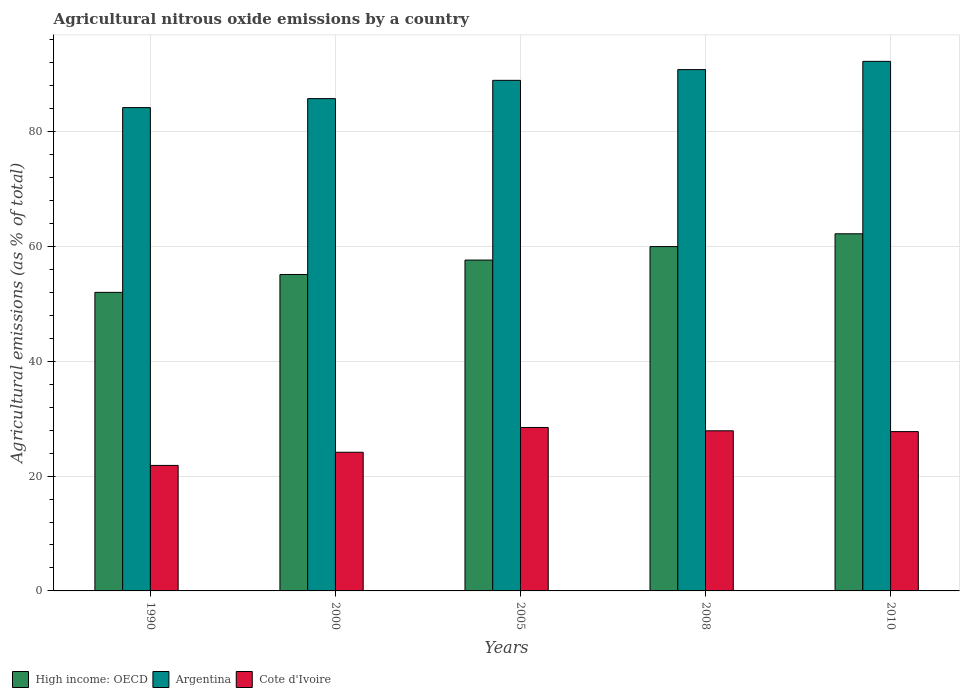How many groups of bars are there?
Offer a very short reply. 5. Are the number of bars per tick equal to the number of legend labels?
Provide a short and direct response. Yes. Are the number of bars on each tick of the X-axis equal?
Provide a succinct answer. Yes. What is the label of the 3rd group of bars from the left?
Your response must be concise. 2005. What is the amount of agricultural nitrous oxide emitted in Cote d'Ivoire in 2010?
Offer a very short reply. 27.74. Across all years, what is the maximum amount of agricultural nitrous oxide emitted in Argentina?
Keep it short and to the point. 92.22. Across all years, what is the minimum amount of agricultural nitrous oxide emitted in Argentina?
Keep it short and to the point. 84.16. In which year was the amount of agricultural nitrous oxide emitted in Argentina maximum?
Ensure brevity in your answer.  2010. In which year was the amount of agricultural nitrous oxide emitted in Argentina minimum?
Make the answer very short. 1990. What is the total amount of agricultural nitrous oxide emitted in Argentina in the graph?
Offer a very short reply. 441.8. What is the difference between the amount of agricultural nitrous oxide emitted in High income: OECD in 1990 and that in 2008?
Give a very brief answer. -7.97. What is the difference between the amount of agricultural nitrous oxide emitted in Argentina in 2008 and the amount of agricultural nitrous oxide emitted in High income: OECD in 1990?
Give a very brief answer. 38.79. What is the average amount of agricultural nitrous oxide emitted in Cote d'Ivoire per year?
Your answer should be compact. 26.02. In the year 2000, what is the difference between the amount of agricultural nitrous oxide emitted in High income: OECD and amount of agricultural nitrous oxide emitted in Cote d'Ivoire?
Your response must be concise. 30.96. What is the ratio of the amount of agricultural nitrous oxide emitted in High income: OECD in 1990 to that in 2005?
Keep it short and to the point. 0.9. Is the difference between the amount of agricultural nitrous oxide emitted in High income: OECD in 1990 and 2010 greater than the difference between the amount of agricultural nitrous oxide emitted in Cote d'Ivoire in 1990 and 2010?
Make the answer very short. No. What is the difference between the highest and the second highest amount of agricultural nitrous oxide emitted in Cote d'Ivoire?
Ensure brevity in your answer.  0.58. What is the difference between the highest and the lowest amount of agricultural nitrous oxide emitted in High income: OECD?
Offer a terse response. 10.2. In how many years, is the amount of agricultural nitrous oxide emitted in Cote d'Ivoire greater than the average amount of agricultural nitrous oxide emitted in Cote d'Ivoire taken over all years?
Provide a short and direct response. 3. Is the sum of the amount of agricultural nitrous oxide emitted in Cote d'Ivoire in 1990 and 2008 greater than the maximum amount of agricultural nitrous oxide emitted in Argentina across all years?
Offer a terse response. No. What does the 1st bar from the left in 2008 represents?
Offer a terse response. High income: OECD. What does the 3rd bar from the right in 2000 represents?
Give a very brief answer. High income: OECD. Is it the case that in every year, the sum of the amount of agricultural nitrous oxide emitted in Cote d'Ivoire and amount of agricultural nitrous oxide emitted in Argentina is greater than the amount of agricultural nitrous oxide emitted in High income: OECD?
Offer a terse response. Yes. How many bars are there?
Provide a succinct answer. 15. Are all the bars in the graph horizontal?
Make the answer very short. No. How many years are there in the graph?
Offer a terse response. 5. How many legend labels are there?
Your answer should be very brief. 3. What is the title of the graph?
Offer a very short reply. Agricultural nitrous oxide emissions by a country. What is the label or title of the X-axis?
Offer a terse response. Years. What is the label or title of the Y-axis?
Give a very brief answer. Agricultural emissions (as % of total). What is the Agricultural emissions (as % of total) in High income: OECD in 1990?
Offer a terse response. 51.99. What is the Agricultural emissions (as % of total) of Argentina in 1990?
Ensure brevity in your answer.  84.16. What is the Agricultural emissions (as % of total) of Cote d'Ivoire in 1990?
Keep it short and to the point. 21.85. What is the Agricultural emissions (as % of total) of High income: OECD in 2000?
Ensure brevity in your answer.  55.1. What is the Agricultural emissions (as % of total) in Argentina in 2000?
Ensure brevity in your answer.  85.73. What is the Agricultural emissions (as % of total) of Cote d'Ivoire in 2000?
Give a very brief answer. 24.15. What is the Agricultural emissions (as % of total) of High income: OECD in 2005?
Your answer should be very brief. 57.61. What is the Agricultural emissions (as % of total) of Argentina in 2005?
Your response must be concise. 88.91. What is the Agricultural emissions (as % of total) in Cote d'Ivoire in 2005?
Offer a very short reply. 28.46. What is the Agricultural emissions (as % of total) in High income: OECD in 2008?
Provide a short and direct response. 59.96. What is the Agricultural emissions (as % of total) of Argentina in 2008?
Keep it short and to the point. 90.78. What is the Agricultural emissions (as % of total) of Cote d'Ivoire in 2008?
Provide a succinct answer. 27.88. What is the Agricultural emissions (as % of total) of High income: OECD in 2010?
Your answer should be very brief. 62.19. What is the Agricultural emissions (as % of total) in Argentina in 2010?
Keep it short and to the point. 92.22. What is the Agricultural emissions (as % of total) of Cote d'Ivoire in 2010?
Your response must be concise. 27.74. Across all years, what is the maximum Agricultural emissions (as % of total) in High income: OECD?
Offer a very short reply. 62.19. Across all years, what is the maximum Agricultural emissions (as % of total) in Argentina?
Keep it short and to the point. 92.22. Across all years, what is the maximum Agricultural emissions (as % of total) of Cote d'Ivoire?
Keep it short and to the point. 28.46. Across all years, what is the minimum Agricultural emissions (as % of total) in High income: OECD?
Provide a succinct answer. 51.99. Across all years, what is the minimum Agricultural emissions (as % of total) in Argentina?
Offer a terse response. 84.16. Across all years, what is the minimum Agricultural emissions (as % of total) in Cote d'Ivoire?
Provide a succinct answer. 21.85. What is the total Agricultural emissions (as % of total) of High income: OECD in the graph?
Ensure brevity in your answer.  286.86. What is the total Agricultural emissions (as % of total) in Argentina in the graph?
Offer a terse response. 441.8. What is the total Agricultural emissions (as % of total) in Cote d'Ivoire in the graph?
Offer a terse response. 130.09. What is the difference between the Agricultural emissions (as % of total) of High income: OECD in 1990 and that in 2000?
Your answer should be compact. -3.12. What is the difference between the Agricultural emissions (as % of total) in Argentina in 1990 and that in 2000?
Provide a short and direct response. -1.56. What is the difference between the Agricultural emissions (as % of total) of Cote d'Ivoire in 1990 and that in 2000?
Give a very brief answer. -2.29. What is the difference between the Agricultural emissions (as % of total) in High income: OECD in 1990 and that in 2005?
Ensure brevity in your answer.  -5.62. What is the difference between the Agricultural emissions (as % of total) of Argentina in 1990 and that in 2005?
Ensure brevity in your answer.  -4.75. What is the difference between the Agricultural emissions (as % of total) in Cote d'Ivoire in 1990 and that in 2005?
Your answer should be very brief. -6.61. What is the difference between the Agricultural emissions (as % of total) of High income: OECD in 1990 and that in 2008?
Ensure brevity in your answer.  -7.97. What is the difference between the Agricultural emissions (as % of total) in Argentina in 1990 and that in 2008?
Offer a very short reply. -6.62. What is the difference between the Agricultural emissions (as % of total) in Cote d'Ivoire in 1990 and that in 2008?
Ensure brevity in your answer.  -6.03. What is the difference between the Agricultural emissions (as % of total) in High income: OECD in 1990 and that in 2010?
Offer a very short reply. -10.2. What is the difference between the Agricultural emissions (as % of total) of Argentina in 1990 and that in 2010?
Your answer should be very brief. -8.05. What is the difference between the Agricultural emissions (as % of total) in Cote d'Ivoire in 1990 and that in 2010?
Give a very brief answer. -5.89. What is the difference between the Agricultural emissions (as % of total) of High income: OECD in 2000 and that in 2005?
Provide a short and direct response. -2.51. What is the difference between the Agricultural emissions (as % of total) of Argentina in 2000 and that in 2005?
Offer a terse response. -3.18. What is the difference between the Agricultural emissions (as % of total) of Cote d'Ivoire in 2000 and that in 2005?
Give a very brief answer. -4.31. What is the difference between the Agricultural emissions (as % of total) in High income: OECD in 2000 and that in 2008?
Offer a terse response. -4.86. What is the difference between the Agricultural emissions (as % of total) of Argentina in 2000 and that in 2008?
Provide a succinct answer. -5.05. What is the difference between the Agricultural emissions (as % of total) in Cote d'Ivoire in 2000 and that in 2008?
Your answer should be compact. -3.73. What is the difference between the Agricultural emissions (as % of total) of High income: OECD in 2000 and that in 2010?
Provide a short and direct response. -7.09. What is the difference between the Agricultural emissions (as % of total) in Argentina in 2000 and that in 2010?
Your response must be concise. -6.49. What is the difference between the Agricultural emissions (as % of total) in Cote d'Ivoire in 2000 and that in 2010?
Your response must be concise. -3.6. What is the difference between the Agricultural emissions (as % of total) of High income: OECD in 2005 and that in 2008?
Your answer should be very brief. -2.35. What is the difference between the Agricultural emissions (as % of total) in Argentina in 2005 and that in 2008?
Your response must be concise. -1.87. What is the difference between the Agricultural emissions (as % of total) in Cote d'Ivoire in 2005 and that in 2008?
Your answer should be very brief. 0.58. What is the difference between the Agricultural emissions (as % of total) in High income: OECD in 2005 and that in 2010?
Your answer should be very brief. -4.58. What is the difference between the Agricultural emissions (as % of total) in Argentina in 2005 and that in 2010?
Make the answer very short. -3.3. What is the difference between the Agricultural emissions (as % of total) of Cote d'Ivoire in 2005 and that in 2010?
Keep it short and to the point. 0.72. What is the difference between the Agricultural emissions (as % of total) in High income: OECD in 2008 and that in 2010?
Your answer should be very brief. -2.23. What is the difference between the Agricultural emissions (as % of total) of Argentina in 2008 and that in 2010?
Your answer should be compact. -1.44. What is the difference between the Agricultural emissions (as % of total) in Cote d'Ivoire in 2008 and that in 2010?
Your response must be concise. 0.14. What is the difference between the Agricultural emissions (as % of total) in High income: OECD in 1990 and the Agricultural emissions (as % of total) in Argentina in 2000?
Keep it short and to the point. -33.74. What is the difference between the Agricultural emissions (as % of total) in High income: OECD in 1990 and the Agricultural emissions (as % of total) in Cote d'Ivoire in 2000?
Your answer should be very brief. 27.84. What is the difference between the Agricultural emissions (as % of total) of Argentina in 1990 and the Agricultural emissions (as % of total) of Cote d'Ivoire in 2000?
Offer a terse response. 60.02. What is the difference between the Agricultural emissions (as % of total) of High income: OECD in 1990 and the Agricultural emissions (as % of total) of Argentina in 2005?
Your response must be concise. -36.92. What is the difference between the Agricultural emissions (as % of total) of High income: OECD in 1990 and the Agricultural emissions (as % of total) of Cote d'Ivoire in 2005?
Give a very brief answer. 23.53. What is the difference between the Agricultural emissions (as % of total) of Argentina in 1990 and the Agricultural emissions (as % of total) of Cote d'Ivoire in 2005?
Your answer should be very brief. 55.7. What is the difference between the Agricultural emissions (as % of total) in High income: OECD in 1990 and the Agricultural emissions (as % of total) in Argentina in 2008?
Offer a very short reply. -38.79. What is the difference between the Agricultural emissions (as % of total) of High income: OECD in 1990 and the Agricultural emissions (as % of total) of Cote d'Ivoire in 2008?
Offer a terse response. 24.11. What is the difference between the Agricultural emissions (as % of total) of Argentina in 1990 and the Agricultural emissions (as % of total) of Cote d'Ivoire in 2008?
Provide a succinct answer. 56.28. What is the difference between the Agricultural emissions (as % of total) of High income: OECD in 1990 and the Agricultural emissions (as % of total) of Argentina in 2010?
Your answer should be very brief. -40.23. What is the difference between the Agricultural emissions (as % of total) in High income: OECD in 1990 and the Agricultural emissions (as % of total) in Cote d'Ivoire in 2010?
Offer a terse response. 24.24. What is the difference between the Agricultural emissions (as % of total) of Argentina in 1990 and the Agricultural emissions (as % of total) of Cote d'Ivoire in 2010?
Give a very brief answer. 56.42. What is the difference between the Agricultural emissions (as % of total) of High income: OECD in 2000 and the Agricultural emissions (as % of total) of Argentina in 2005?
Your response must be concise. -33.81. What is the difference between the Agricultural emissions (as % of total) of High income: OECD in 2000 and the Agricultural emissions (as % of total) of Cote d'Ivoire in 2005?
Provide a succinct answer. 26.64. What is the difference between the Agricultural emissions (as % of total) of Argentina in 2000 and the Agricultural emissions (as % of total) of Cote d'Ivoire in 2005?
Make the answer very short. 57.27. What is the difference between the Agricultural emissions (as % of total) in High income: OECD in 2000 and the Agricultural emissions (as % of total) in Argentina in 2008?
Ensure brevity in your answer.  -35.68. What is the difference between the Agricultural emissions (as % of total) of High income: OECD in 2000 and the Agricultural emissions (as % of total) of Cote d'Ivoire in 2008?
Offer a terse response. 27.22. What is the difference between the Agricultural emissions (as % of total) of Argentina in 2000 and the Agricultural emissions (as % of total) of Cote d'Ivoire in 2008?
Offer a very short reply. 57.85. What is the difference between the Agricultural emissions (as % of total) in High income: OECD in 2000 and the Agricultural emissions (as % of total) in Argentina in 2010?
Provide a succinct answer. -37.11. What is the difference between the Agricultural emissions (as % of total) of High income: OECD in 2000 and the Agricultural emissions (as % of total) of Cote d'Ivoire in 2010?
Ensure brevity in your answer.  27.36. What is the difference between the Agricultural emissions (as % of total) in Argentina in 2000 and the Agricultural emissions (as % of total) in Cote d'Ivoire in 2010?
Provide a succinct answer. 57.98. What is the difference between the Agricultural emissions (as % of total) in High income: OECD in 2005 and the Agricultural emissions (as % of total) in Argentina in 2008?
Keep it short and to the point. -33.17. What is the difference between the Agricultural emissions (as % of total) in High income: OECD in 2005 and the Agricultural emissions (as % of total) in Cote d'Ivoire in 2008?
Offer a very short reply. 29.73. What is the difference between the Agricultural emissions (as % of total) of Argentina in 2005 and the Agricultural emissions (as % of total) of Cote d'Ivoire in 2008?
Keep it short and to the point. 61.03. What is the difference between the Agricultural emissions (as % of total) in High income: OECD in 2005 and the Agricultural emissions (as % of total) in Argentina in 2010?
Offer a very short reply. -34.6. What is the difference between the Agricultural emissions (as % of total) of High income: OECD in 2005 and the Agricultural emissions (as % of total) of Cote d'Ivoire in 2010?
Offer a terse response. 29.87. What is the difference between the Agricultural emissions (as % of total) of Argentina in 2005 and the Agricultural emissions (as % of total) of Cote d'Ivoire in 2010?
Your response must be concise. 61.17. What is the difference between the Agricultural emissions (as % of total) in High income: OECD in 2008 and the Agricultural emissions (as % of total) in Argentina in 2010?
Provide a succinct answer. -32.25. What is the difference between the Agricultural emissions (as % of total) of High income: OECD in 2008 and the Agricultural emissions (as % of total) of Cote d'Ivoire in 2010?
Keep it short and to the point. 32.22. What is the difference between the Agricultural emissions (as % of total) of Argentina in 2008 and the Agricultural emissions (as % of total) of Cote d'Ivoire in 2010?
Your answer should be compact. 63.04. What is the average Agricultural emissions (as % of total) in High income: OECD per year?
Make the answer very short. 57.37. What is the average Agricultural emissions (as % of total) in Argentina per year?
Offer a very short reply. 88.36. What is the average Agricultural emissions (as % of total) in Cote d'Ivoire per year?
Your answer should be compact. 26.02. In the year 1990, what is the difference between the Agricultural emissions (as % of total) in High income: OECD and Agricultural emissions (as % of total) in Argentina?
Ensure brevity in your answer.  -32.18. In the year 1990, what is the difference between the Agricultural emissions (as % of total) in High income: OECD and Agricultural emissions (as % of total) in Cote d'Ivoire?
Your response must be concise. 30.13. In the year 1990, what is the difference between the Agricultural emissions (as % of total) of Argentina and Agricultural emissions (as % of total) of Cote d'Ivoire?
Provide a short and direct response. 62.31. In the year 2000, what is the difference between the Agricultural emissions (as % of total) in High income: OECD and Agricultural emissions (as % of total) in Argentina?
Provide a short and direct response. -30.62. In the year 2000, what is the difference between the Agricultural emissions (as % of total) of High income: OECD and Agricultural emissions (as % of total) of Cote d'Ivoire?
Your response must be concise. 30.96. In the year 2000, what is the difference between the Agricultural emissions (as % of total) in Argentina and Agricultural emissions (as % of total) in Cote d'Ivoire?
Your answer should be very brief. 61.58. In the year 2005, what is the difference between the Agricultural emissions (as % of total) in High income: OECD and Agricultural emissions (as % of total) in Argentina?
Give a very brief answer. -31.3. In the year 2005, what is the difference between the Agricultural emissions (as % of total) of High income: OECD and Agricultural emissions (as % of total) of Cote d'Ivoire?
Offer a terse response. 29.15. In the year 2005, what is the difference between the Agricultural emissions (as % of total) in Argentina and Agricultural emissions (as % of total) in Cote d'Ivoire?
Make the answer very short. 60.45. In the year 2008, what is the difference between the Agricultural emissions (as % of total) of High income: OECD and Agricultural emissions (as % of total) of Argentina?
Offer a terse response. -30.82. In the year 2008, what is the difference between the Agricultural emissions (as % of total) of High income: OECD and Agricultural emissions (as % of total) of Cote d'Ivoire?
Offer a very short reply. 32.08. In the year 2008, what is the difference between the Agricultural emissions (as % of total) in Argentina and Agricultural emissions (as % of total) in Cote d'Ivoire?
Ensure brevity in your answer.  62.9. In the year 2010, what is the difference between the Agricultural emissions (as % of total) in High income: OECD and Agricultural emissions (as % of total) in Argentina?
Keep it short and to the point. -30.03. In the year 2010, what is the difference between the Agricultural emissions (as % of total) in High income: OECD and Agricultural emissions (as % of total) in Cote d'Ivoire?
Provide a succinct answer. 34.45. In the year 2010, what is the difference between the Agricultural emissions (as % of total) of Argentina and Agricultural emissions (as % of total) of Cote d'Ivoire?
Offer a very short reply. 64.47. What is the ratio of the Agricultural emissions (as % of total) of High income: OECD in 1990 to that in 2000?
Ensure brevity in your answer.  0.94. What is the ratio of the Agricultural emissions (as % of total) of Argentina in 1990 to that in 2000?
Your response must be concise. 0.98. What is the ratio of the Agricultural emissions (as % of total) in Cote d'Ivoire in 1990 to that in 2000?
Offer a terse response. 0.91. What is the ratio of the Agricultural emissions (as % of total) in High income: OECD in 1990 to that in 2005?
Ensure brevity in your answer.  0.9. What is the ratio of the Agricultural emissions (as % of total) of Argentina in 1990 to that in 2005?
Give a very brief answer. 0.95. What is the ratio of the Agricultural emissions (as % of total) of Cote d'Ivoire in 1990 to that in 2005?
Offer a terse response. 0.77. What is the ratio of the Agricultural emissions (as % of total) in High income: OECD in 1990 to that in 2008?
Make the answer very short. 0.87. What is the ratio of the Agricultural emissions (as % of total) of Argentina in 1990 to that in 2008?
Provide a short and direct response. 0.93. What is the ratio of the Agricultural emissions (as % of total) of Cote d'Ivoire in 1990 to that in 2008?
Offer a very short reply. 0.78. What is the ratio of the Agricultural emissions (as % of total) of High income: OECD in 1990 to that in 2010?
Provide a succinct answer. 0.84. What is the ratio of the Agricultural emissions (as % of total) in Argentina in 1990 to that in 2010?
Offer a terse response. 0.91. What is the ratio of the Agricultural emissions (as % of total) in Cote d'Ivoire in 1990 to that in 2010?
Give a very brief answer. 0.79. What is the ratio of the Agricultural emissions (as % of total) in High income: OECD in 2000 to that in 2005?
Provide a short and direct response. 0.96. What is the ratio of the Agricultural emissions (as % of total) in Argentina in 2000 to that in 2005?
Offer a very short reply. 0.96. What is the ratio of the Agricultural emissions (as % of total) of Cote d'Ivoire in 2000 to that in 2005?
Ensure brevity in your answer.  0.85. What is the ratio of the Agricultural emissions (as % of total) of High income: OECD in 2000 to that in 2008?
Offer a very short reply. 0.92. What is the ratio of the Agricultural emissions (as % of total) of Argentina in 2000 to that in 2008?
Offer a terse response. 0.94. What is the ratio of the Agricultural emissions (as % of total) of Cote d'Ivoire in 2000 to that in 2008?
Keep it short and to the point. 0.87. What is the ratio of the Agricultural emissions (as % of total) in High income: OECD in 2000 to that in 2010?
Ensure brevity in your answer.  0.89. What is the ratio of the Agricultural emissions (as % of total) of Argentina in 2000 to that in 2010?
Keep it short and to the point. 0.93. What is the ratio of the Agricultural emissions (as % of total) in Cote d'Ivoire in 2000 to that in 2010?
Provide a short and direct response. 0.87. What is the ratio of the Agricultural emissions (as % of total) in High income: OECD in 2005 to that in 2008?
Your answer should be very brief. 0.96. What is the ratio of the Agricultural emissions (as % of total) in Argentina in 2005 to that in 2008?
Give a very brief answer. 0.98. What is the ratio of the Agricultural emissions (as % of total) of Cote d'Ivoire in 2005 to that in 2008?
Provide a succinct answer. 1.02. What is the ratio of the Agricultural emissions (as % of total) in High income: OECD in 2005 to that in 2010?
Offer a very short reply. 0.93. What is the ratio of the Agricultural emissions (as % of total) in Argentina in 2005 to that in 2010?
Make the answer very short. 0.96. What is the ratio of the Agricultural emissions (as % of total) in Cote d'Ivoire in 2005 to that in 2010?
Offer a very short reply. 1.03. What is the ratio of the Agricultural emissions (as % of total) in High income: OECD in 2008 to that in 2010?
Ensure brevity in your answer.  0.96. What is the ratio of the Agricultural emissions (as % of total) of Argentina in 2008 to that in 2010?
Provide a succinct answer. 0.98. What is the ratio of the Agricultural emissions (as % of total) in Cote d'Ivoire in 2008 to that in 2010?
Make the answer very short. 1. What is the difference between the highest and the second highest Agricultural emissions (as % of total) in High income: OECD?
Your answer should be compact. 2.23. What is the difference between the highest and the second highest Agricultural emissions (as % of total) in Argentina?
Give a very brief answer. 1.44. What is the difference between the highest and the second highest Agricultural emissions (as % of total) of Cote d'Ivoire?
Make the answer very short. 0.58. What is the difference between the highest and the lowest Agricultural emissions (as % of total) of High income: OECD?
Your response must be concise. 10.2. What is the difference between the highest and the lowest Agricultural emissions (as % of total) in Argentina?
Your response must be concise. 8.05. What is the difference between the highest and the lowest Agricultural emissions (as % of total) of Cote d'Ivoire?
Give a very brief answer. 6.61. 